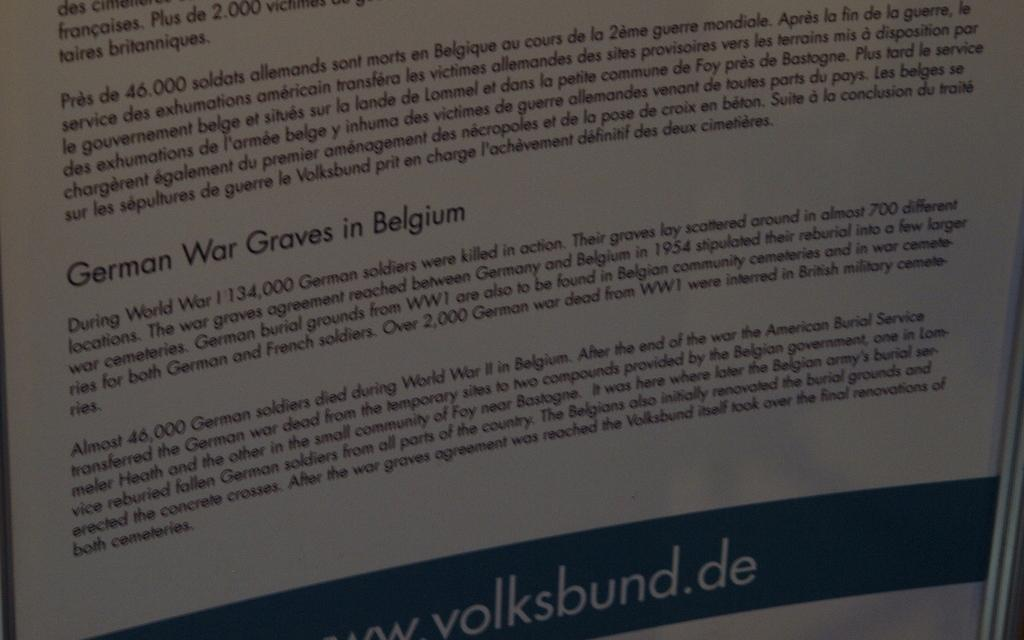What is present in the image that is used for displaying information or messages? There is a banner in the image. What colors are used for the banner in the image? The banner is white and green in color. What can be seen on the banner in terms of text or writing? There are words written on the banner. What color are the words on the banner? The words on the banner are written in black color. How does the banner teach people about wind energy in the image? The banner does not teach people about wind energy in the image; it only displays words in black on a white and green background. 